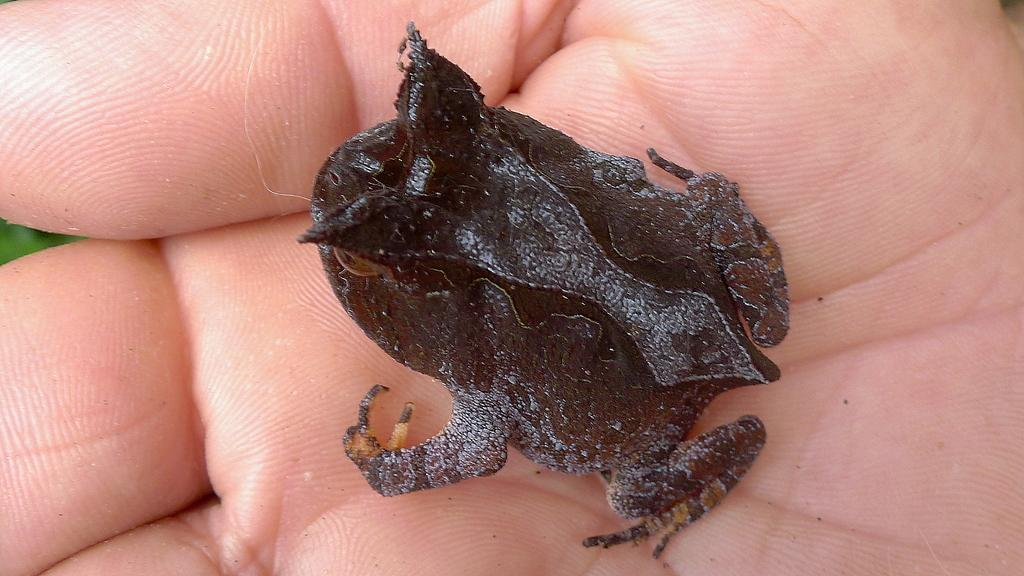What can be seen in the foreground of the image? There is a person's hand visible in the foreground of the image. What is the person holding in the image? The person is holding a frog. What type of shirt is the person wearing in the image? There is no shirt visible in the image, as only the person's hand is shown. Is the person wearing a hat in the image? There is no hat visible in the image, as only the person's hand is shown. 